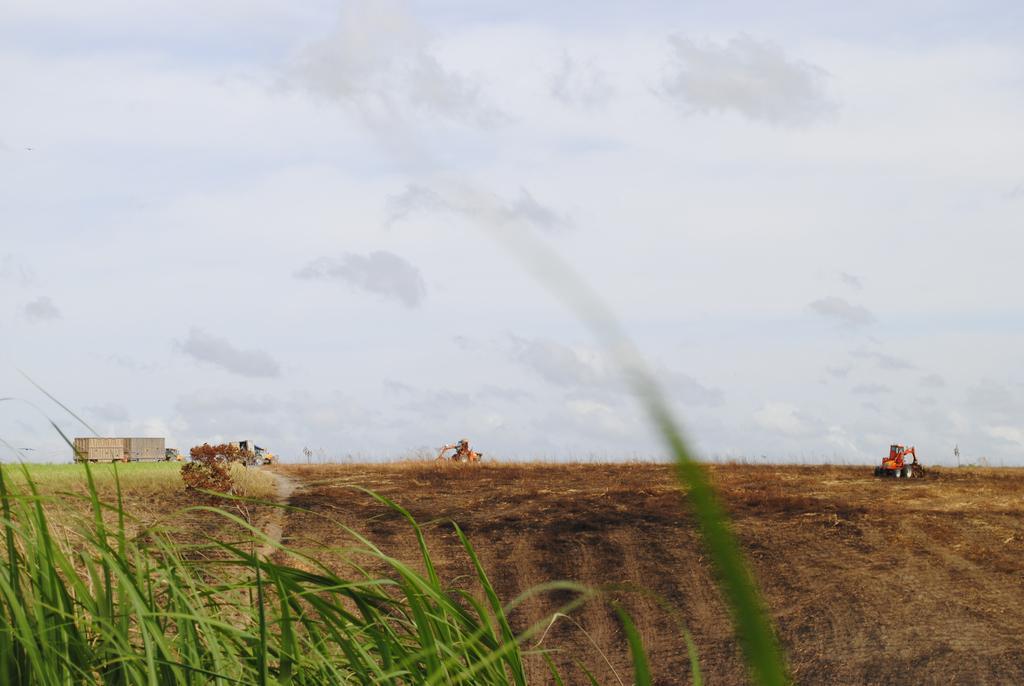In one or two sentences, can you explain what this image depicts? In this image we can see a field, there is the vehicle, where is the grass, at above here is the sky. 